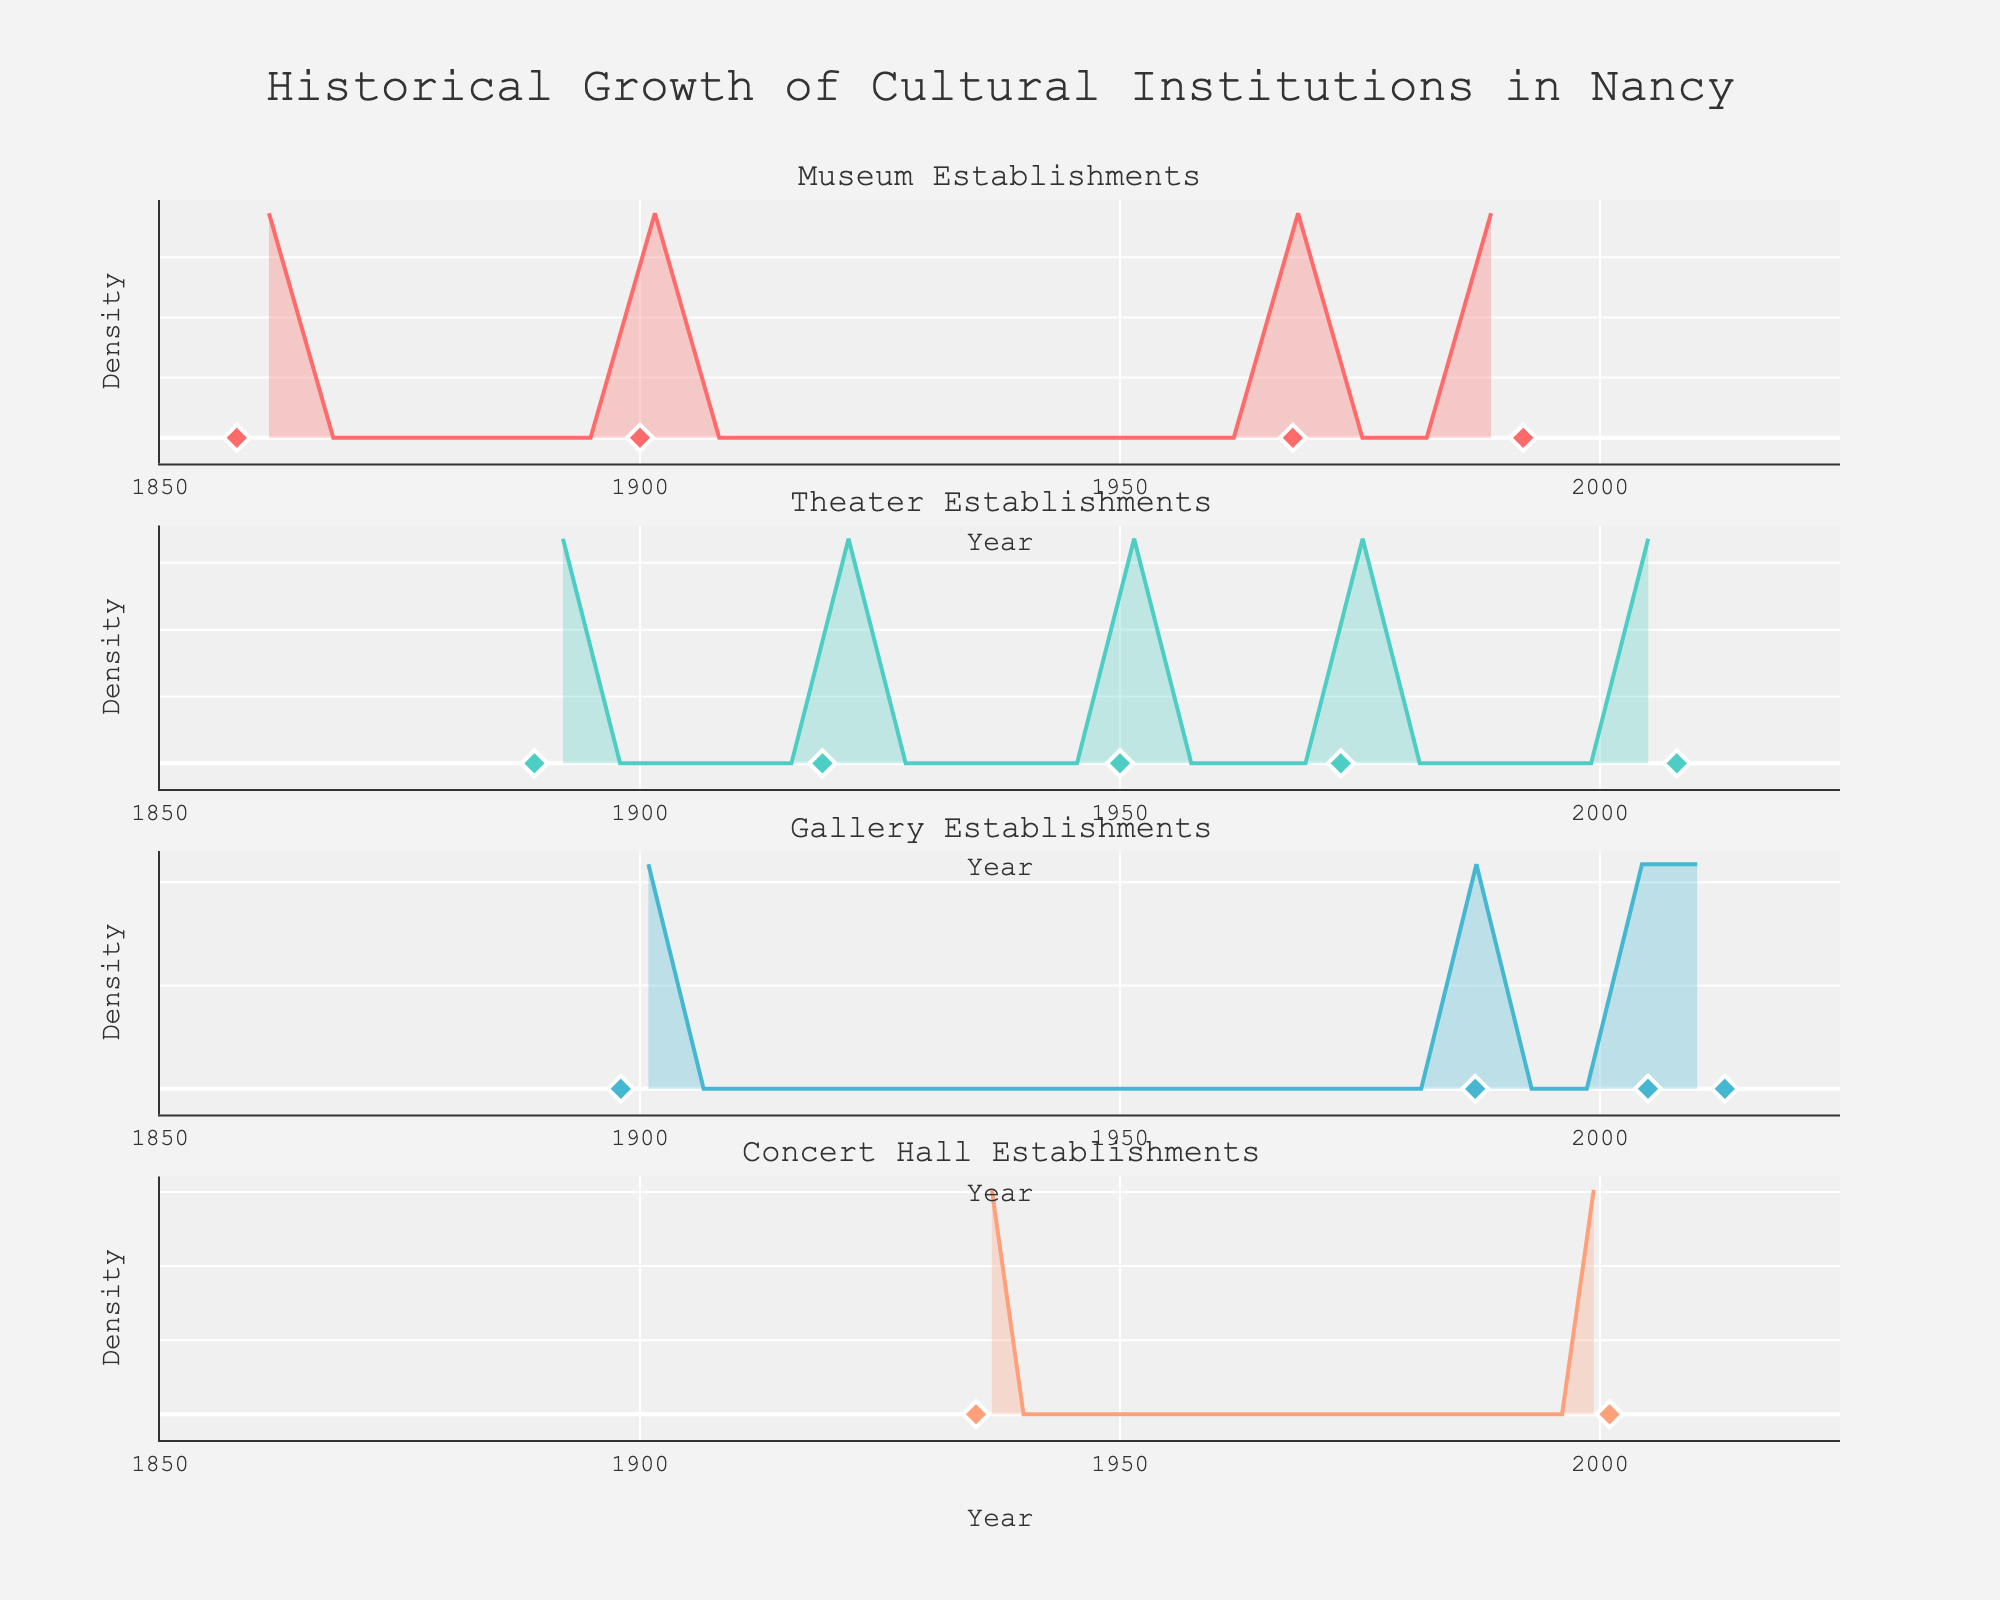What is the title of the figure? The title of the figure is usually placed at the top of the plot and summarizes the main content and focus.
Answer: Historical Growth of Cultural Institutions in Nancy How many different types of cultural institutions are displayed in the figure? The subplot titles indicate the growth of different types of cultural institutions. By counting these titles, one can identify the number of institution types.
Answer: 5 In which year did the density of Theater establishments peak? Look at the subplot for Theater establishments and identify the year where the density curve reaches its highest point.
Answer: Around 1950 Which cultural institution had the first establishment listed in the data? By examining the subplots and finding the earliest year marked on any subplot, we can identify which type of institution was established first.
Answer: Museum (1858) How many Theater establishments were founded before 1950? Refer to the markers in the Theater subplot and count the number of points before the year 1950.
Answer: 2 (1889 and 1919) Which decade saw the highest density of new Museums being founded? Examine the density plot for Museums and find the decade (10-year period) where the density curve is highest.
Answer: 1980s Compare the density of Gallery establishments between 1890-1900 and 2000-2010. Which period had a higher density? Look at the Gallery subplot and compare the heights of the density curves between the specified periods. The higher curve indicates a higher density.
Answer: 2000-2010 What year were the most recent cultural institutions established according to the figure? Check the latest year marked by a diamond marker in each subplot, then identify the most recent year across all subplots.
Answer: 2013 How do the densities of Museum and Theater establishments between 1900 and 1950 compare? Examine the density plots for both Museums and Theaters within this period and observe which plot shows a higher density curve.
Answer: Museums have a higher density Which type of institution has the most dispersed establishment years? A wider and less peaked density plot indicates more dispersed establishment years. Compare the widths and peaks of the density plots for each institution type.
Answer: Galleries 